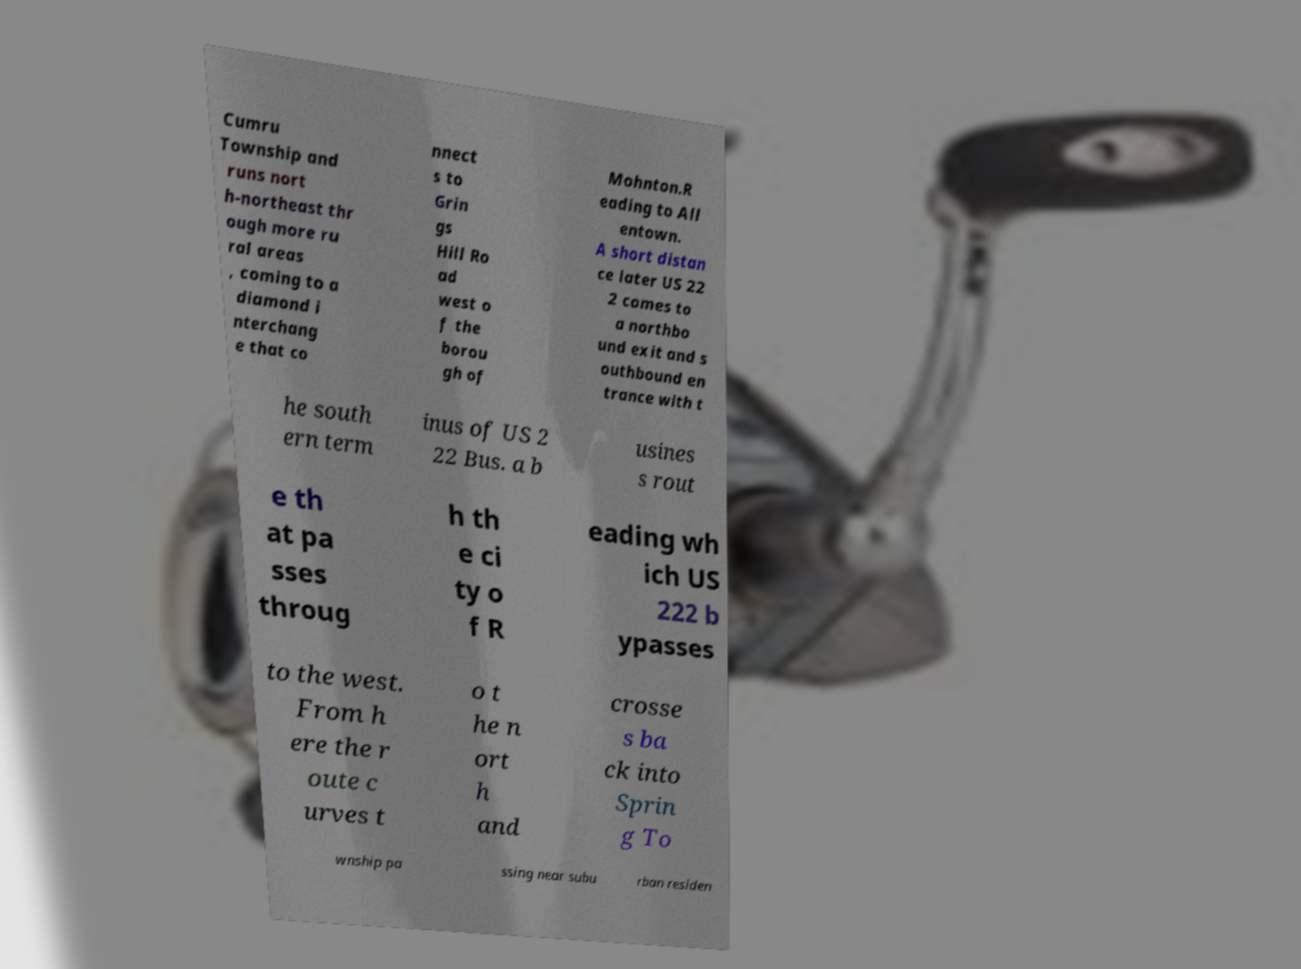Could you extract and type out the text from this image? Cumru Township and runs nort h-northeast thr ough more ru ral areas , coming to a diamond i nterchang e that co nnect s to Grin gs Hill Ro ad west o f the borou gh of Mohnton.R eading to All entown. A short distan ce later US 22 2 comes to a northbo und exit and s outhbound en trance with t he south ern term inus of US 2 22 Bus. a b usines s rout e th at pa sses throug h th e ci ty o f R eading wh ich US 222 b ypasses to the west. From h ere the r oute c urves t o t he n ort h and crosse s ba ck into Sprin g To wnship pa ssing near subu rban residen 